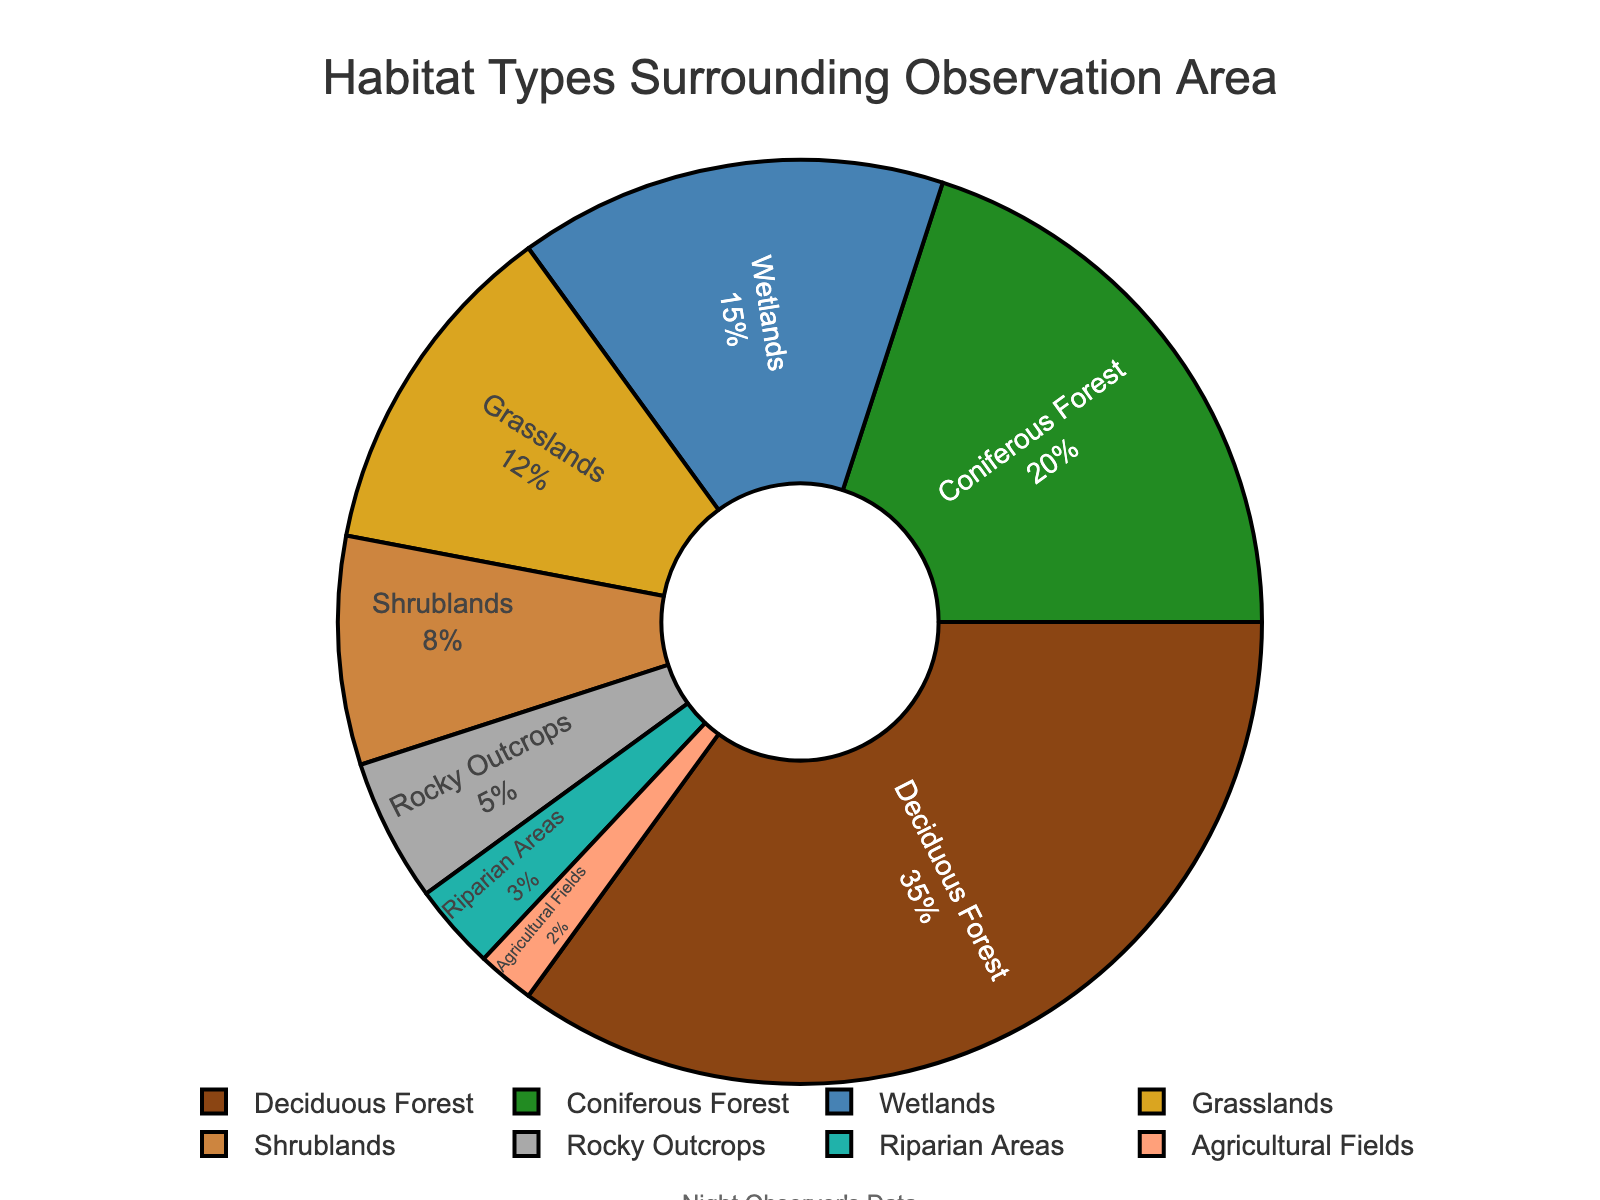What is the habitat type with the largest percentage? The pie chart segments each habitat type and labels them with their respective percentages. By observing the largest labeled segment, we can identify the habitat type with the largest percentage.
Answer: Deciduous Forest Which habitat types together make up more than 50% of the area? First, identify the percentages of each habitat type. Then, sum the percentages starting from the largest until the total exceeds 50%.
Answer: Deciduous Forest and Coniferous Forest What is the difference in percentage between Shrublands and Rocky Outcrops? By looking at the pie chart segments labeled "Shrublands" and "Rocky Outcrops," note their individual percentages and subtract the smaller value from the larger one.
Answer: 3% How do Wetlands compare to Grasslands in terms of percentage? Compare the labeled segments for "Wetlands" and "Grasslands." Note their percentages and determine which is larger or if they are equal.
Answer: Wetlands have a higher percentage than Grasslands What percentage of the area is covered by non-forest habitats (excluding Deciduous and Coniferous Forest)? Exclude the percentages for Deciduous Forest (35%) and Coniferous Forest (20%). Sum the remaining percentages: Wetlands (15%), Grasslands (12%), Shrublands (8%), Rocky Outcrops (5%), Riparian Areas (3%), and Agricultural Fields (2%).
Answer: 45% Which habitat types have percentages less than 10%? Identify which segments in the pie chart have percentages lower than 10% by looking at their labels.
Answer: Shrublands, Rocky Outcrops, Riparian Areas, and Agricultural Fields If you combine Grasslands and Shrublands, what percentage of the total area do they cover? Add the percentages of Grasslands (12%) and Shrublands (8%) as labeled in the pie chart.
Answer: 20% What is the cumulative percentage of the three smallest habitat types? Identify the three smallest segments by percentage: Agricultural Fields (2%), Riparian Areas (3%), and Rocky Outcrops (5%). Sum these percentages.
Answer: 10% Are there more hectares covered by Rocky Outcrops or by Riparian Areas? Compared to Rocky Outcrops (5%) and Riparian Areas (3%), observe which percentage is larger.
Answer: Rocky Outcrops What is the relationship between the percentages of Agricultural Fields and Riparian Areas? Compare the percentages labeled for Agricultural Fields (2%) and Riparian Areas (3%) to see which is larger, smaller, or if they are equal.
Answer: Riparian Areas cover a larger percentage than Agricultural Fields 